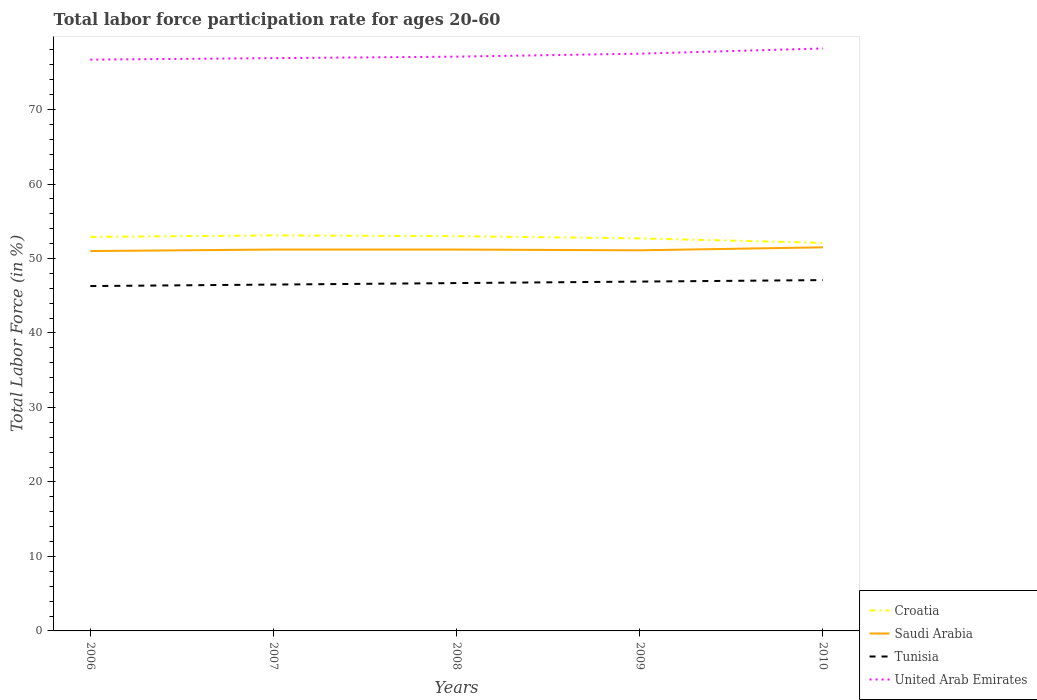Is the number of lines equal to the number of legend labels?
Offer a very short reply. Yes. In which year was the labor force participation rate in United Arab Emirates maximum?
Provide a short and direct response. 2006. What is the difference between the highest and the lowest labor force participation rate in United Arab Emirates?
Offer a very short reply. 2. Is the labor force participation rate in United Arab Emirates strictly greater than the labor force participation rate in Tunisia over the years?
Your response must be concise. No. How many years are there in the graph?
Offer a terse response. 5. What is the difference between two consecutive major ticks on the Y-axis?
Ensure brevity in your answer.  10. Are the values on the major ticks of Y-axis written in scientific E-notation?
Ensure brevity in your answer.  No. Does the graph contain any zero values?
Make the answer very short. No. How are the legend labels stacked?
Give a very brief answer. Vertical. What is the title of the graph?
Ensure brevity in your answer.  Total labor force participation rate for ages 20-60. What is the Total Labor Force (in %) of Croatia in 2006?
Give a very brief answer. 52.9. What is the Total Labor Force (in %) of Tunisia in 2006?
Keep it short and to the point. 46.3. What is the Total Labor Force (in %) of United Arab Emirates in 2006?
Ensure brevity in your answer.  76.7. What is the Total Labor Force (in %) of Croatia in 2007?
Offer a very short reply. 53.1. What is the Total Labor Force (in %) of Saudi Arabia in 2007?
Your response must be concise. 51.2. What is the Total Labor Force (in %) in Tunisia in 2007?
Your answer should be very brief. 46.5. What is the Total Labor Force (in %) in United Arab Emirates in 2007?
Offer a terse response. 76.9. What is the Total Labor Force (in %) in Saudi Arabia in 2008?
Offer a very short reply. 51.2. What is the Total Labor Force (in %) of Tunisia in 2008?
Offer a terse response. 46.7. What is the Total Labor Force (in %) of United Arab Emirates in 2008?
Offer a terse response. 77.1. What is the Total Labor Force (in %) of Croatia in 2009?
Keep it short and to the point. 52.7. What is the Total Labor Force (in %) of Saudi Arabia in 2009?
Your answer should be compact. 51.1. What is the Total Labor Force (in %) in Tunisia in 2009?
Your answer should be very brief. 46.9. What is the Total Labor Force (in %) of United Arab Emirates in 2009?
Provide a short and direct response. 77.5. What is the Total Labor Force (in %) in Croatia in 2010?
Make the answer very short. 52.1. What is the Total Labor Force (in %) of Saudi Arabia in 2010?
Ensure brevity in your answer.  51.5. What is the Total Labor Force (in %) of Tunisia in 2010?
Ensure brevity in your answer.  47.1. What is the Total Labor Force (in %) of United Arab Emirates in 2010?
Provide a short and direct response. 78.2. Across all years, what is the maximum Total Labor Force (in %) of Croatia?
Ensure brevity in your answer.  53.1. Across all years, what is the maximum Total Labor Force (in %) in Saudi Arabia?
Your response must be concise. 51.5. Across all years, what is the maximum Total Labor Force (in %) of Tunisia?
Your response must be concise. 47.1. Across all years, what is the maximum Total Labor Force (in %) of United Arab Emirates?
Ensure brevity in your answer.  78.2. Across all years, what is the minimum Total Labor Force (in %) of Croatia?
Keep it short and to the point. 52.1. Across all years, what is the minimum Total Labor Force (in %) of Tunisia?
Keep it short and to the point. 46.3. Across all years, what is the minimum Total Labor Force (in %) in United Arab Emirates?
Ensure brevity in your answer.  76.7. What is the total Total Labor Force (in %) of Croatia in the graph?
Offer a terse response. 263.8. What is the total Total Labor Force (in %) of Saudi Arabia in the graph?
Keep it short and to the point. 256. What is the total Total Labor Force (in %) of Tunisia in the graph?
Give a very brief answer. 233.5. What is the total Total Labor Force (in %) of United Arab Emirates in the graph?
Keep it short and to the point. 386.4. What is the difference between the Total Labor Force (in %) in Croatia in 2006 and that in 2007?
Offer a very short reply. -0.2. What is the difference between the Total Labor Force (in %) in Saudi Arabia in 2006 and that in 2008?
Offer a very short reply. -0.2. What is the difference between the Total Labor Force (in %) of Tunisia in 2006 and that in 2008?
Make the answer very short. -0.4. What is the difference between the Total Labor Force (in %) of United Arab Emirates in 2006 and that in 2008?
Ensure brevity in your answer.  -0.4. What is the difference between the Total Labor Force (in %) in Croatia in 2006 and that in 2009?
Provide a succinct answer. 0.2. What is the difference between the Total Labor Force (in %) in Tunisia in 2006 and that in 2009?
Ensure brevity in your answer.  -0.6. What is the difference between the Total Labor Force (in %) in United Arab Emirates in 2006 and that in 2009?
Your response must be concise. -0.8. What is the difference between the Total Labor Force (in %) in Croatia in 2006 and that in 2010?
Offer a terse response. 0.8. What is the difference between the Total Labor Force (in %) of Saudi Arabia in 2006 and that in 2010?
Keep it short and to the point. -0.5. What is the difference between the Total Labor Force (in %) of Croatia in 2007 and that in 2008?
Your answer should be compact. 0.1. What is the difference between the Total Labor Force (in %) of Saudi Arabia in 2007 and that in 2008?
Your answer should be very brief. 0. What is the difference between the Total Labor Force (in %) in United Arab Emirates in 2007 and that in 2009?
Keep it short and to the point. -0.6. What is the difference between the Total Labor Force (in %) of Croatia in 2007 and that in 2010?
Your answer should be very brief. 1. What is the difference between the Total Labor Force (in %) of Saudi Arabia in 2007 and that in 2010?
Give a very brief answer. -0.3. What is the difference between the Total Labor Force (in %) of Tunisia in 2007 and that in 2010?
Provide a succinct answer. -0.6. What is the difference between the Total Labor Force (in %) in United Arab Emirates in 2007 and that in 2010?
Your answer should be compact. -1.3. What is the difference between the Total Labor Force (in %) of United Arab Emirates in 2008 and that in 2009?
Give a very brief answer. -0.4. What is the difference between the Total Labor Force (in %) in Croatia in 2008 and that in 2010?
Provide a short and direct response. 0.9. What is the difference between the Total Labor Force (in %) of United Arab Emirates in 2008 and that in 2010?
Make the answer very short. -1.1. What is the difference between the Total Labor Force (in %) of Croatia in 2009 and that in 2010?
Keep it short and to the point. 0.6. What is the difference between the Total Labor Force (in %) in Saudi Arabia in 2009 and that in 2010?
Provide a short and direct response. -0.4. What is the difference between the Total Labor Force (in %) in Croatia in 2006 and the Total Labor Force (in %) in Saudi Arabia in 2007?
Your answer should be very brief. 1.7. What is the difference between the Total Labor Force (in %) in Saudi Arabia in 2006 and the Total Labor Force (in %) in Tunisia in 2007?
Ensure brevity in your answer.  4.5. What is the difference between the Total Labor Force (in %) in Saudi Arabia in 2006 and the Total Labor Force (in %) in United Arab Emirates in 2007?
Your answer should be very brief. -25.9. What is the difference between the Total Labor Force (in %) in Tunisia in 2006 and the Total Labor Force (in %) in United Arab Emirates in 2007?
Your answer should be very brief. -30.6. What is the difference between the Total Labor Force (in %) of Croatia in 2006 and the Total Labor Force (in %) of United Arab Emirates in 2008?
Your answer should be very brief. -24.2. What is the difference between the Total Labor Force (in %) in Saudi Arabia in 2006 and the Total Labor Force (in %) in Tunisia in 2008?
Offer a terse response. 4.3. What is the difference between the Total Labor Force (in %) in Saudi Arabia in 2006 and the Total Labor Force (in %) in United Arab Emirates in 2008?
Your answer should be compact. -26.1. What is the difference between the Total Labor Force (in %) in Tunisia in 2006 and the Total Labor Force (in %) in United Arab Emirates in 2008?
Your response must be concise. -30.8. What is the difference between the Total Labor Force (in %) of Croatia in 2006 and the Total Labor Force (in %) of Saudi Arabia in 2009?
Provide a short and direct response. 1.8. What is the difference between the Total Labor Force (in %) in Croatia in 2006 and the Total Labor Force (in %) in United Arab Emirates in 2009?
Your answer should be compact. -24.6. What is the difference between the Total Labor Force (in %) of Saudi Arabia in 2006 and the Total Labor Force (in %) of United Arab Emirates in 2009?
Your answer should be compact. -26.5. What is the difference between the Total Labor Force (in %) of Tunisia in 2006 and the Total Labor Force (in %) of United Arab Emirates in 2009?
Give a very brief answer. -31.2. What is the difference between the Total Labor Force (in %) in Croatia in 2006 and the Total Labor Force (in %) in Tunisia in 2010?
Keep it short and to the point. 5.8. What is the difference between the Total Labor Force (in %) of Croatia in 2006 and the Total Labor Force (in %) of United Arab Emirates in 2010?
Give a very brief answer. -25.3. What is the difference between the Total Labor Force (in %) of Saudi Arabia in 2006 and the Total Labor Force (in %) of United Arab Emirates in 2010?
Your answer should be compact. -27.2. What is the difference between the Total Labor Force (in %) of Tunisia in 2006 and the Total Labor Force (in %) of United Arab Emirates in 2010?
Give a very brief answer. -31.9. What is the difference between the Total Labor Force (in %) in Croatia in 2007 and the Total Labor Force (in %) in Tunisia in 2008?
Provide a short and direct response. 6.4. What is the difference between the Total Labor Force (in %) in Croatia in 2007 and the Total Labor Force (in %) in United Arab Emirates in 2008?
Provide a short and direct response. -24. What is the difference between the Total Labor Force (in %) of Saudi Arabia in 2007 and the Total Labor Force (in %) of Tunisia in 2008?
Offer a terse response. 4.5. What is the difference between the Total Labor Force (in %) in Saudi Arabia in 2007 and the Total Labor Force (in %) in United Arab Emirates in 2008?
Offer a terse response. -25.9. What is the difference between the Total Labor Force (in %) of Tunisia in 2007 and the Total Labor Force (in %) of United Arab Emirates in 2008?
Ensure brevity in your answer.  -30.6. What is the difference between the Total Labor Force (in %) in Croatia in 2007 and the Total Labor Force (in %) in United Arab Emirates in 2009?
Your answer should be very brief. -24.4. What is the difference between the Total Labor Force (in %) in Saudi Arabia in 2007 and the Total Labor Force (in %) in Tunisia in 2009?
Keep it short and to the point. 4.3. What is the difference between the Total Labor Force (in %) of Saudi Arabia in 2007 and the Total Labor Force (in %) of United Arab Emirates in 2009?
Provide a succinct answer. -26.3. What is the difference between the Total Labor Force (in %) of Tunisia in 2007 and the Total Labor Force (in %) of United Arab Emirates in 2009?
Ensure brevity in your answer.  -31. What is the difference between the Total Labor Force (in %) of Croatia in 2007 and the Total Labor Force (in %) of United Arab Emirates in 2010?
Make the answer very short. -25.1. What is the difference between the Total Labor Force (in %) in Tunisia in 2007 and the Total Labor Force (in %) in United Arab Emirates in 2010?
Ensure brevity in your answer.  -31.7. What is the difference between the Total Labor Force (in %) in Croatia in 2008 and the Total Labor Force (in %) in United Arab Emirates in 2009?
Provide a short and direct response. -24.5. What is the difference between the Total Labor Force (in %) in Saudi Arabia in 2008 and the Total Labor Force (in %) in Tunisia in 2009?
Give a very brief answer. 4.3. What is the difference between the Total Labor Force (in %) in Saudi Arabia in 2008 and the Total Labor Force (in %) in United Arab Emirates in 2009?
Provide a succinct answer. -26.3. What is the difference between the Total Labor Force (in %) of Tunisia in 2008 and the Total Labor Force (in %) of United Arab Emirates in 2009?
Your answer should be very brief. -30.8. What is the difference between the Total Labor Force (in %) in Croatia in 2008 and the Total Labor Force (in %) in Saudi Arabia in 2010?
Offer a very short reply. 1.5. What is the difference between the Total Labor Force (in %) in Croatia in 2008 and the Total Labor Force (in %) in Tunisia in 2010?
Provide a succinct answer. 5.9. What is the difference between the Total Labor Force (in %) in Croatia in 2008 and the Total Labor Force (in %) in United Arab Emirates in 2010?
Your answer should be compact. -25.2. What is the difference between the Total Labor Force (in %) in Saudi Arabia in 2008 and the Total Labor Force (in %) in United Arab Emirates in 2010?
Keep it short and to the point. -27. What is the difference between the Total Labor Force (in %) in Tunisia in 2008 and the Total Labor Force (in %) in United Arab Emirates in 2010?
Offer a very short reply. -31.5. What is the difference between the Total Labor Force (in %) in Croatia in 2009 and the Total Labor Force (in %) in Tunisia in 2010?
Offer a terse response. 5.6. What is the difference between the Total Labor Force (in %) in Croatia in 2009 and the Total Labor Force (in %) in United Arab Emirates in 2010?
Your answer should be very brief. -25.5. What is the difference between the Total Labor Force (in %) in Saudi Arabia in 2009 and the Total Labor Force (in %) in Tunisia in 2010?
Provide a succinct answer. 4. What is the difference between the Total Labor Force (in %) of Saudi Arabia in 2009 and the Total Labor Force (in %) of United Arab Emirates in 2010?
Make the answer very short. -27.1. What is the difference between the Total Labor Force (in %) in Tunisia in 2009 and the Total Labor Force (in %) in United Arab Emirates in 2010?
Ensure brevity in your answer.  -31.3. What is the average Total Labor Force (in %) in Croatia per year?
Your answer should be very brief. 52.76. What is the average Total Labor Force (in %) in Saudi Arabia per year?
Your answer should be compact. 51.2. What is the average Total Labor Force (in %) in Tunisia per year?
Your answer should be very brief. 46.7. What is the average Total Labor Force (in %) of United Arab Emirates per year?
Provide a succinct answer. 77.28. In the year 2006, what is the difference between the Total Labor Force (in %) in Croatia and Total Labor Force (in %) in Saudi Arabia?
Make the answer very short. 1.9. In the year 2006, what is the difference between the Total Labor Force (in %) of Croatia and Total Labor Force (in %) of United Arab Emirates?
Offer a terse response. -23.8. In the year 2006, what is the difference between the Total Labor Force (in %) in Saudi Arabia and Total Labor Force (in %) in Tunisia?
Your answer should be compact. 4.7. In the year 2006, what is the difference between the Total Labor Force (in %) of Saudi Arabia and Total Labor Force (in %) of United Arab Emirates?
Offer a terse response. -25.7. In the year 2006, what is the difference between the Total Labor Force (in %) in Tunisia and Total Labor Force (in %) in United Arab Emirates?
Your response must be concise. -30.4. In the year 2007, what is the difference between the Total Labor Force (in %) in Croatia and Total Labor Force (in %) in Saudi Arabia?
Provide a succinct answer. 1.9. In the year 2007, what is the difference between the Total Labor Force (in %) in Croatia and Total Labor Force (in %) in Tunisia?
Provide a short and direct response. 6.6. In the year 2007, what is the difference between the Total Labor Force (in %) in Croatia and Total Labor Force (in %) in United Arab Emirates?
Provide a short and direct response. -23.8. In the year 2007, what is the difference between the Total Labor Force (in %) of Saudi Arabia and Total Labor Force (in %) of United Arab Emirates?
Offer a very short reply. -25.7. In the year 2007, what is the difference between the Total Labor Force (in %) of Tunisia and Total Labor Force (in %) of United Arab Emirates?
Your answer should be very brief. -30.4. In the year 2008, what is the difference between the Total Labor Force (in %) of Croatia and Total Labor Force (in %) of United Arab Emirates?
Offer a terse response. -24.1. In the year 2008, what is the difference between the Total Labor Force (in %) of Saudi Arabia and Total Labor Force (in %) of Tunisia?
Your response must be concise. 4.5. In the year 2008, what is the difference between the Total Labor Force (in %) in Saudi Arabia and Total Labor Force (in %) in United Arab Emirates?
Keep it short and to the point. -25.9. In the year 2008, what is the difference between the Total Labor Force (in %) of Tunisia and Total Labor Force (in %) of United Arab Emirates?
Your answer should be compact. -30.4. In the year 2009, what is the difference between the Total Labor Force (in %) in Croatia and Total Labor Force (in %) in Saudi Arabia?
Your response must be concise. 1.6. In the year 2009, what is the difference between the Total Labor Force (in %) of Croatia and Total Labor Force (in %) of United Arab Emirates?
Make the answer very short. -24.8. In the year 2009, what is the difference between the Total Labor Force (in %) in Saudi Arabia and Total Labor Force (in %) in Tunisia?
Your response must be concise. 4.2. In the year 2009, what is the difference between the Total Labor Force (in %) of Saudi Arabia and Total Labor Force (in %) of United Arab Emirates?
Ensure brevity in your answer.  -26.4. In the year 2009, what is the difference between the Total Labor Force (in %) of Tunisia and Total Labor Force (in %) of United Arab Emirates?
Provide a short and direct response. -30.6. In the year 2010, what is the difference between the Total Labor Force (in %) in Croatia and Total Labor Force (in %) in Saudi Arabia?
Make the answer very short. 0.6. In the year 2010, what is the difference between the Total Labor Force (in %) in Croatia and Total Labor Force (in %) in United Arab Emirates?
Provide a short and direct response. -26.1. In the year 2010, what is the difference between the Total Labor Force (in %) in Saudi Arabia and Total Labor Force (in %) in Tunisia?
Offer a terse response. 4.4. In the year 2010, what is the difference between the Total Labor Force (in %) in Saudi Arabia and Total Labor Force (in %) in United Arab Emirates?
Make the answer very short. -26.7. In the year 2010, what is the difference between the Total Labor Force (in %) in Tunisia and Total Labor Force (in %) in United Arab Emirates?
Your answer should be compact. -31.1. What is the ratio of the Total Labor Force (in %) in Croatia in 2006 to that in 2007?
Keep it short and to the point. 1. What is the ratio of the Total Labor Force (in %) in Saudi Arabia in 2006 to that in 2007?
Keep it short and to the point. 1. What is the ratio of the Total Labor Force (in %) of Tunisia in 2006 to that in 2007?
Make the answer very short. 1. What is the ratio of the Total Labor Force (in %) of United Arab Emirates in 2006 to that in 2007?
Provide a succinct answer. 1. What is the ratio of the Total Labor Force (in %) in Croatia in 2006 to that in 2008?
Provide a succinct answer. 1. What is the ratio of the Total Labor Force (in %) in Tunisia in 2006 to that in 2008?
Offer a very short reply. 0.99. What is the ratio of the Total Labor Force (in %) in United Arab Emirates in 2006 to that in 2008?
Ensure brevity in your answer.  0.99. What is the ratio of the Total Labor Force (in %) in Croatia in 2006 to that in 2009?
Provide a short and direct response. 1. What is the ratio of the Total Labor Force (in %) of Saudi Arabia in 2006 to that in 2009?
Offer a terse response. 1. What is the ratio of the Total Labor Force (in %) of Tunisia in 2006 to that in 2009?
Your answer should be compact. 0.99. What is the ratio of the Total Labor Force (in %) in United Arab Emirates in 2006 to that in 2009?
Give a very brief answer. 0.99. What is the ratio of the Total Labor Force (in %) in Croatia in 2006 to that in 2010?
Make the answer very short. 1.02. What is the ratio of the Total Labor Force (in %) of Saudi Arabia in 2006 to that in 2010?
Give a very brief answer. 0.99. What is the ratio of the Total Labor Force (in %) in Tunisia in 2006 to that in 2010?
Keep it short and to the point. 0.98. What is the ratio of the Total Labor Force (in %) in United Arab Emirates in 2006 to that in 2010?
Provide a short and direct response. 0.98. What is the ratio of the Total Labor Force (in %) of United Arab Emirates in 2007 to that in 2008?
Provide a short and direct response. 1. What is the ratio of the Total Labor Force (in %) in Croatia in 2007 to that in 2009?
Make the answer very short. 1.01. What is the ratio of the Total Labor Force (in %) in Tunisia in 2007 to that in 2009?
Your answer should be compact. 0.99. What is the ratio of the Total Labor Force (in %) in Croatia in 2007 to that in 2010?
Offer a terse response. 1.02. What is the ratio of the Total Labor Force (in %) of Saudi Arabia in 2007 to that in 2010?
Give a very brief answer. 0.99. What is the ratio of the Total Labor Force (in %) in Tunisia in 2007 to that in 2010?
Make the answer very short. 0.99. What is the ratio of the Total Labor Force (in %) in United Arab Emirates in 2007 to that in 2010?
Your answer should be very brief. 0.98. What is the ratio of the Total Labor Force (in %) in Croatia in 2008 to that in 2009?
Provide a succinct answer. 1.01. What is the ratio of the Total Labor Force (in %) of Croatia in 2008 to that in 2010?
Your answer should be very brief. 1.02. What is the ratio of the Total Labor Force (in %) in United Arab Emirates in 2008 to that in 2010?
Make the answer very short. 0.99. What is the ratio of the Total Labor Force (in %) in Croatia in 2009 to that in 2010?
Offer a very short reply. 1.01. What is the ratio of the Total Labor Force (in %) of Saudi Arabia in 2009 to that in 2010?
Your response must be concise. 0.99. What is the difference between the highest and the second highest Total Labor Force (in %) of Tunisia?
Provide a short and direct response. 0.2. What is the difference between the highest and the second highest Total Labor Force (in %) of United Arab Emirates?
Give a very brief answer. 0.7. What is the difference between the highest and the lowest Total Labor Force (in %) in Saudi Arabia?
Your answer should be very brief. 0.5. 